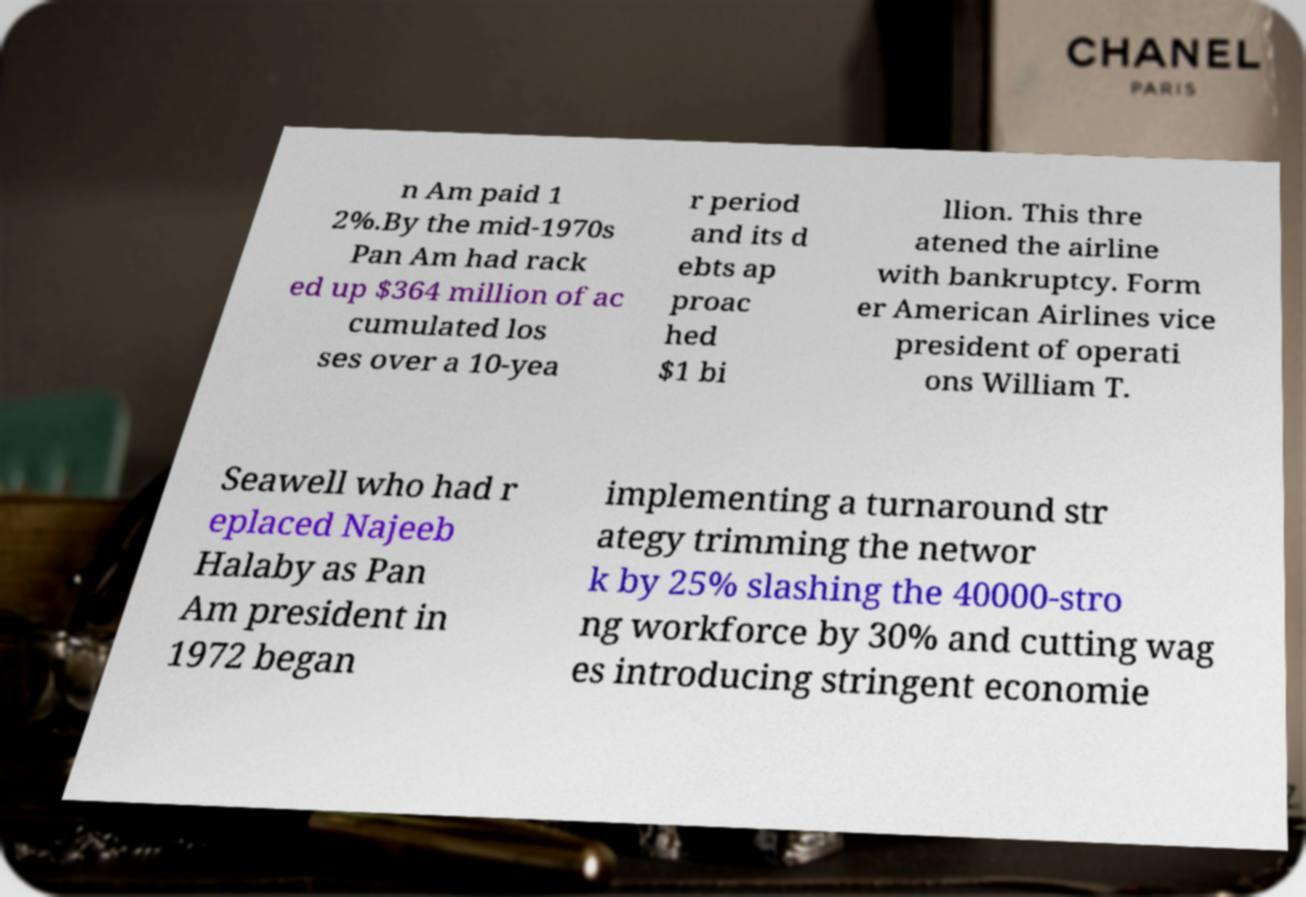I need the written content from this picture converted into text. Can you do that? n Am paid 1 2%.By the mid-1970s Pan Am had rack ed up $364 million of ac cumulated los ses over a 10-yea r period and its d ebts ap proac hed $1 bi llion. This thre atened the airline with bankruptcy. Form er American Airlines vice president of operati ons William T. Seawell who had r eplaced Najeeb Halaby as Pan Am president in 1972 began implementing a turnaround str ategy trimming the networ k by 25% slashing the 40000-stro ng workforce by 30% and cutting wag es introducing stringent economie 